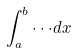Convert formula to latex. <formula><loc_0><loc_0><loc_500><loc_500>\int _ { a } ^ { b } \cdot \cdot \cdot d x</formula> 